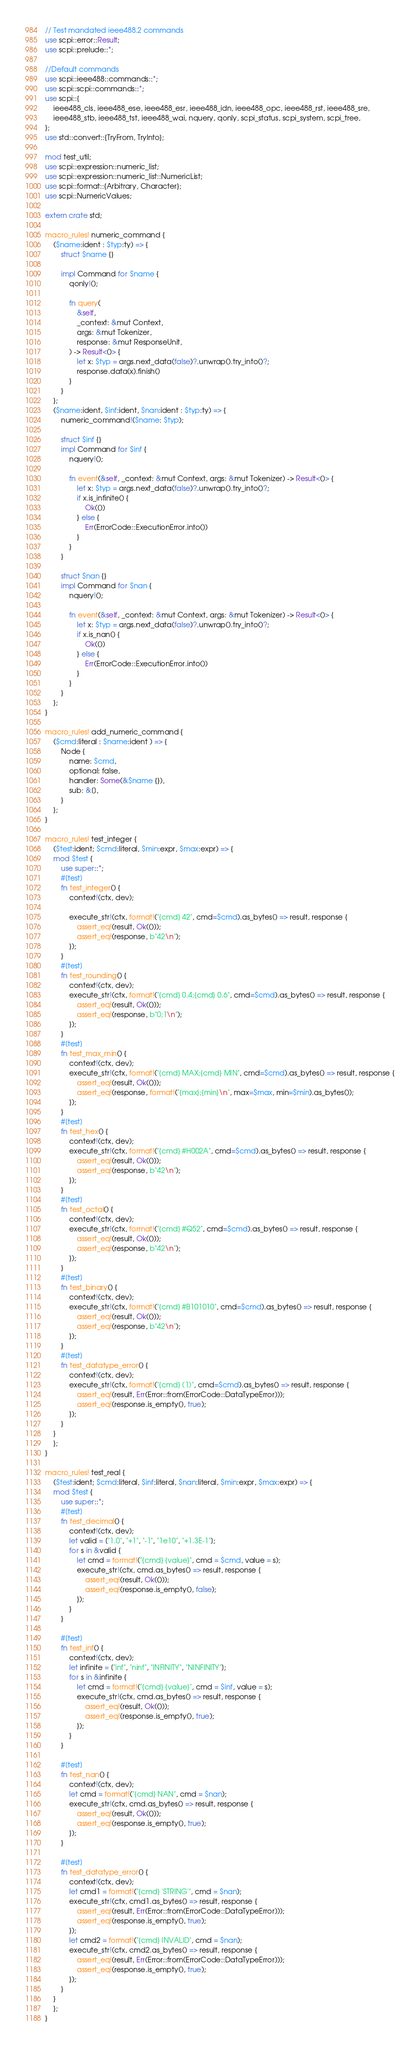<code> <loc_0><loc_0><loc_500><loc_500><_Rust_>// Test mandated ieee488.2 commands
use scpi::error::Result;
use scpi::prelude::*;

//Default commands
use scpi::ieee488::commands::*;
use scpi::scpi::commands::*;
use scpi::{
    ieee488_cls, ieee488_ese, ieee488_esr, ieee488_idn, ieee488_opc, ieee488_rst, ieee488_sre,
    ieee488_stb, ieee488_tst, ieee488_wai, nquery, qonly, scpi_status, scpi_system, scpi_tree,
};
use std::convert::{TryFrom, TryInto};

mod test_util;
use scpi::expression::numeric_list;
use scpi::expression::numeric_list::NumericList;
use scpi::format::{Arbitrary, Character};
use scpi::NumericValues;

extern crate std;

macro_rules! numeric_command {
    ($name:ident : $typ:ty) => {
        struct $name {}

        impl Command for $name {
            qonly!();

            fn query(
                &self,
                _context: &mut Context,
                args: &mut Tokenizer,
                response: &mut ResponseUnit,
            ) -> Result<()> {
                let x: $typ = args.next_data(false)?.unwrap().try_into()?;
                response.data(x).finish()
            }
        }
    };
    ($name:ident, $inf:ident, $nan:ident : $typ:ty) => {
        numeric_command!($name: $typ);

        struct $inf {}
        impl Command for $inf {
            nquery!();

            fn event(&self, _context: &mut Context, args: &mut Tokenizer) -> Result<()> {
                let x: $typ = args.next_data(false)?.unwrap().try_into()?;
                if x.is_infinite() {
                    Ok(())
                } else {
                    Err(ErrorCode::ExecutionError.into())
                }
            }
        }

        struct $nan {}
        impl Command for $nan {
            nquery!();

            fn event(&self, _context: &mut Context, args: &mut Tokenizer) -> Result<()> {
                let x: $typ = args.next_data(false)?.unwrap().try_into()?;
                if x.is_nan() {
                    Ok(())
                } else {
                    Err(ErrorCode::ExecutionError.into())
                }
            }
        }
    };
}

macro_rules! add_numeric_command {
    ($cmd:literal : $name:ident ) => {
        Node {
            name: $cmd,
            optional: false,
            handler: Some(&$name {}),
            sub: &[],
        }
    };
}

macro_rules! test_integer {
    ($test:ident; $cmd:literal, $min:expr, $max:expr) => {
    mod $test {
        use super::*;
        #[test]
        fn test_integer() {
            context!(ctx, dev);

            execute_str!(ctx, format!("{cmd} 42", cmd=$cmd).as_bytes() => result, response {
                assert_eq!(result, Ok(()));
                assert_eq!(response, b"42\n");
            });
        }
        #[test]
        fn test_rounding() {
            context!(ctx, dev);
            execute_str!(ctx, format!("{cmd} 0.4;{cmd} 0.6", cmd=$cmd).as_bytes() => result, response {
                assert_eq!(result, Ok(()));
                assert_eq!(response, b"0;1\n");
            });
        }
        #[test]
        fn test_max_min() {
            context!(ctx, dev);
            execute_str!(ctx, format!("{cmd} MAX;{cmd} MIN", cmd=$cmd).as_bytes() => result, response {
                assert_eq!(result, Ok(()));
                assert_eq!(response, format!("{max};{min}\n", max=$max, min=$min).as_bytes());
            });
        }
        #[test]
        fn test_hex() {
            context!(ctx, dev);
            execute_str!(ctx, format!("{cmd} #H002A", cmd=$cmd).as_bytes() => result, response {
                assert_eq!(result, Ok(()));
                assert_eq!(response, b"42\n");
            });
        }
        #[test]
        fn test_octal() {
            context!(ctx, dev);
            execute_str!(ctx, format!("{cmd} #Q52", cmd=$cmd).as_bytes() => result, response {
                assert_eq!(result, Ok(()));
                assert_eq!(response, b"42\n");
            });
        }
        #[test]
        fn test_binary() {
            context!(ctx, dev);
            execute_str!(ctx, format!("{cmd} #B101010", cmd=$cmd).as_bytes() => result, response {
                assert_eq!(result, Ok(()));
                assert_eq!(response, b"42\n");
            });
        }
        #[test]
        fn test_datatype_error() {
            context!(ctx, dev);
            execute_str!(ctx, format!("{cmd} (1)", cmd=$cmd).as_bytes() => result, response {
                assert_eq!(result, Err(Error::from(ErrorCode::DataTypeError)));
                assert_eq!(response.is_empty(), true);
            });
        }
    }
    };
}

macro_rules! test_real {
    ($test:ident; $cmd:literal, $inf:literal, $nan:literal, $min:expr, $max:expr) => {
    mod $test {
        use super::*;
        #[test]
        fn test_decimal() {
            context!(ctx, dev);
            let valid = ["1.0", "+1", "-1", "1e10", "+1.3E-1"];
            for s in &valid {
                let cmd = format!("{cmd} {value}", cmd = $cmd, value = s);
                execute_str!(ctx, cmd.as_bytes() => result, response {
                    assert_eq!(result, Ok(()));
                    assert_eq!(response.is_empty(), false);
                });
            }
        }

        #[test]
        fn test_inf() {
            context!(ctx, dev);
            let infinite = ["inf", "ninf", "INFINITY", "NINFINITY"];
            for s in &infinite {
                let cmd = format!("{cmd} {value}", cmd = $inf, value = s);
                execute_str!(ctx, cmd.as_bytes() => result, response {
                    assert_eq!(result, Ok(()));
                    assert_eq!(response.is_empty(), true);
                });
            }
        }

        #[test]
        fn test_nan() {
            context!(ctx, dev);
            let cmd = format!("{cmd} NAN", cmd = $nan);
            execute_str!(ctx, cmd.as_bytes() => result, response {
                assert_eq!(result, Ok(()));
                assert_eq!(response.is_empty(), true);
            });
        }

        #[test]
        fn test_datatype_error() {
            context!(ctx, dev);
            let cmd1 = format!("{cmd} 'STRING'", cmd = $nan);
            execute_str!(ctx, cmd1.as_bytes() => result, response {
                assert_eq!(result, Err(Error::from(ErrorCode::DataTypeError)));
                assert_eq!(response.is_empty(), true);
            });
            let cmd2 = format!("{cmd} INVALID", cmd = $nan);
            execute_str!(ctx, cmd2.as_bytes() => result, response {
                assert_eq!(result, Err(Error::from(ErrorCode::DataTypeError)));
                assert_eq!(response.is_empty(), true);
            });
        }
    }
    };
}
</code> 